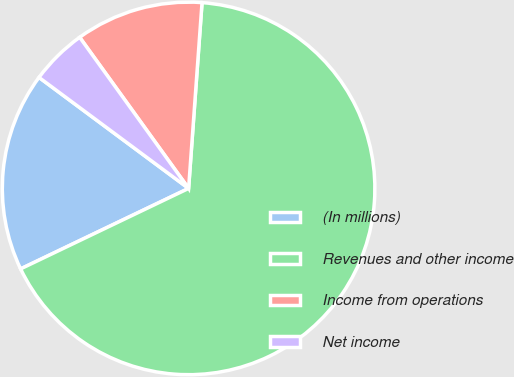<chart> <loc_0><loc_0><loc_500><loc_500><pie_chart><fcel>(In millions)<fcel>Revenues and other income<fcel>Income from operations<fcel>Net income<nl><fcel>17.27%<fcel>66.74%<fcel>11.09%<fcel>4.9%<nl></chart> 